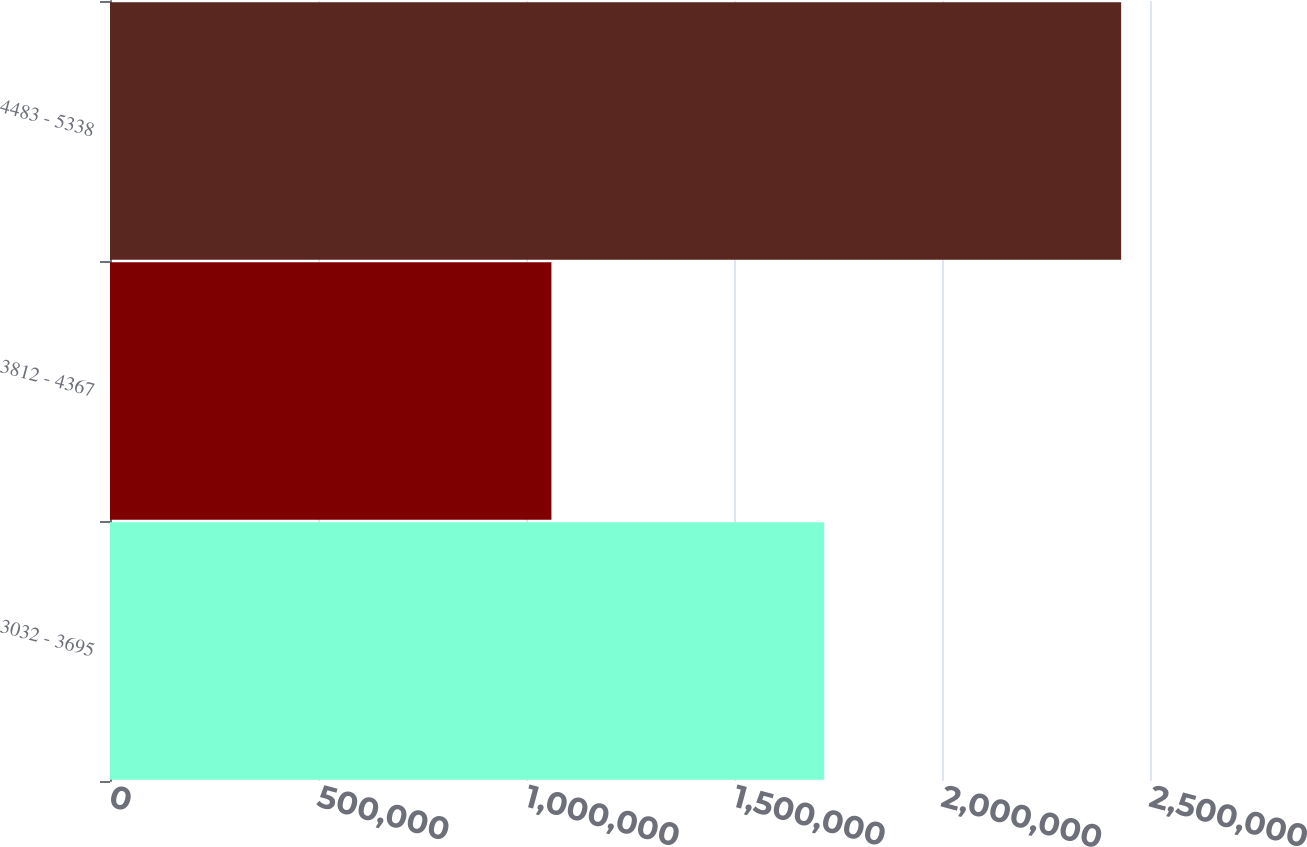Convert chart to OTSL. <chart><loc_0><loc_0><loc_500><loc_500><bar_chart><fcel>3032 - 3695<fcel>3812 - 4367<fcel>4483 - 5338<nl><fcel>1.7169e+06<fcel>1.0611e+06<fcel>2.43065e+06<nl></chart> 